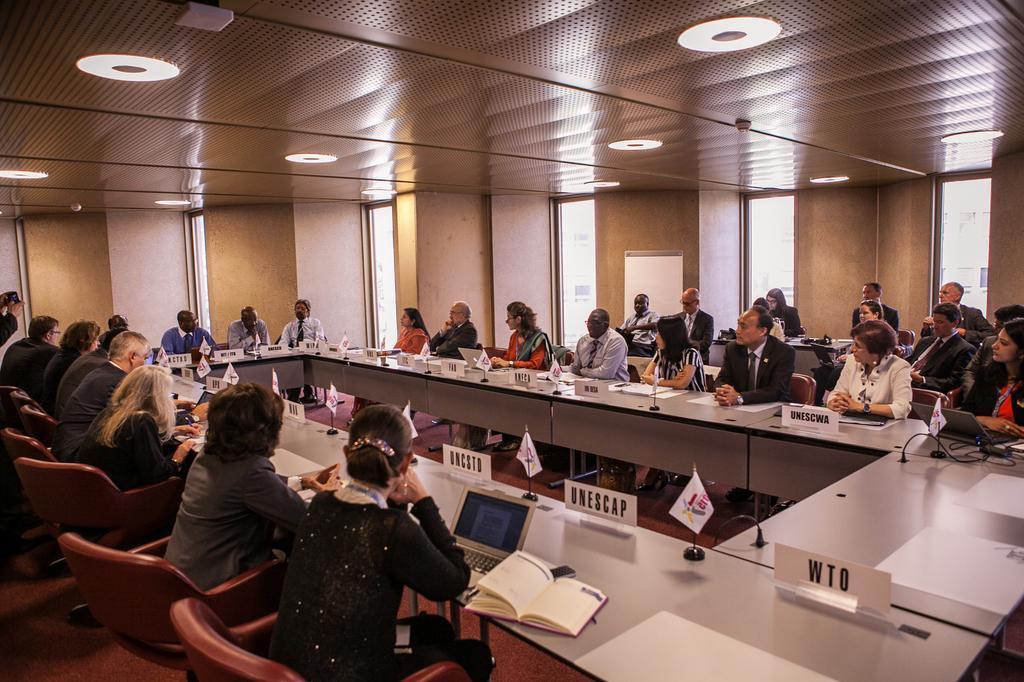In one or two sentences, can you explain what this image depicts? In this image there are group of people sitting on the chairs. This is a table with flags,name boards,laptops,book,and few other things on the table. These are the ceiling lights attached to the rooftop. These are the windows with glass doors. This looks like a board which is white in color. At the left corner of the image I can see a person hand holding an object. 